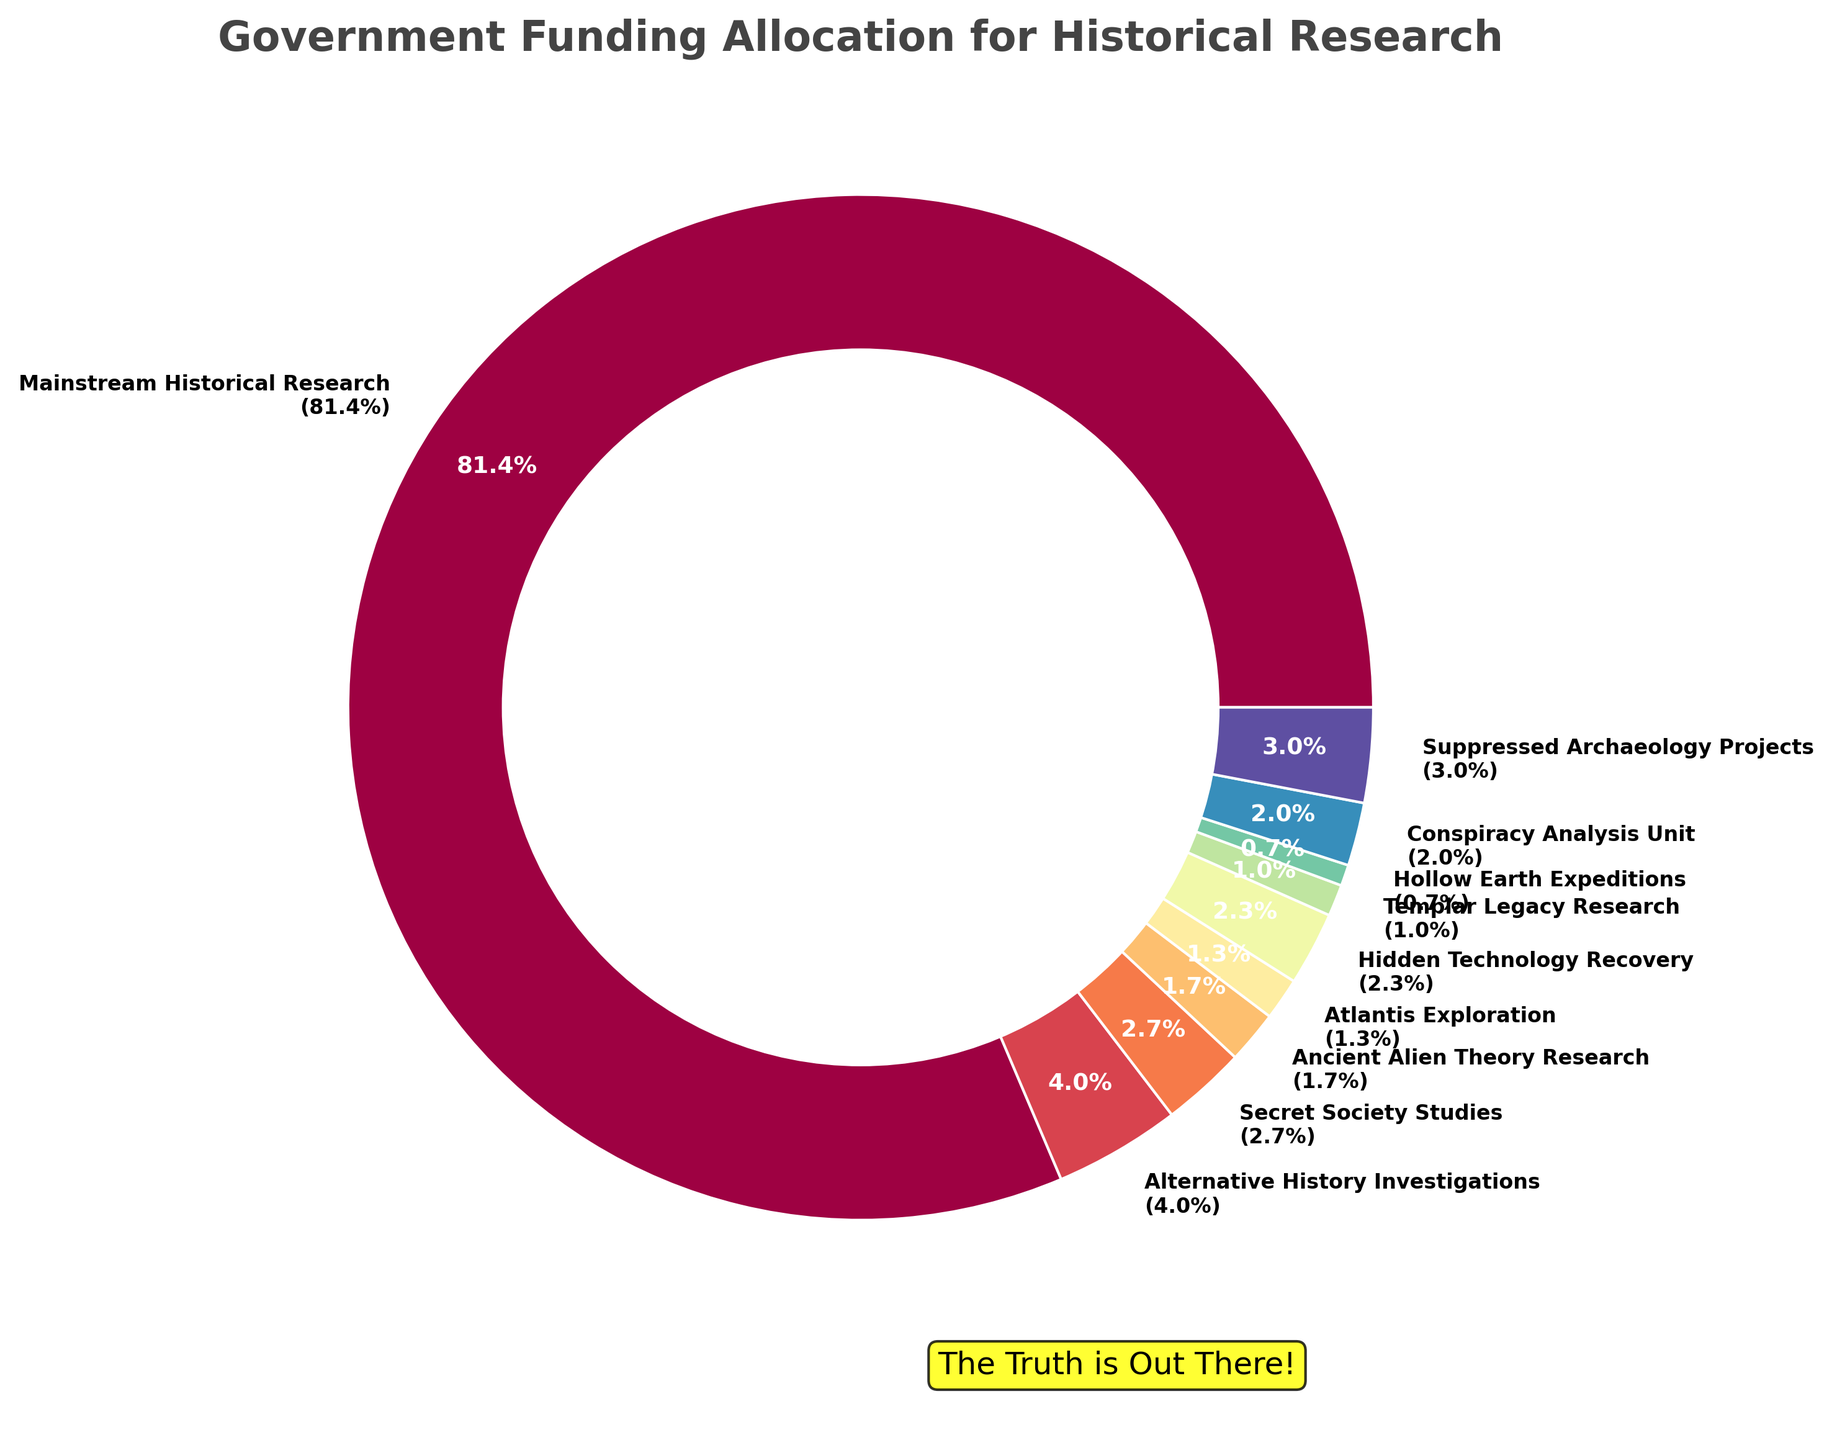Which category receives the highest funding? The segment with the label "Mainstream Historical Research (87.2%)" is the largest and indicates the highest funding.
Answer: Mainstream Historical Research How much more funding does "Mainstream Historical Research" receive compared to "Alternative History Investigations"? "Mainstream Historical Research" receives 245 million €, while "Alternative History Investigations" receives 12 million €. The difference is 245 - 12 = 233 million €.
Answer: 233 million € What is the total percentage of funding allocated to all alternative research categories combined? Sum the percentages of the smaller segments excluding "Mainstream Historical Research". The sum is (4.3+2.9+1.8+1.4+2.5+1.1+0.7+2.1) = 16.1%.
Answer: 16.1% Is the funding for "Conspiracy Analysis Unit" greater than for "Suppressed Archaeology Projects"? "Conspiracy Analysis Unit" receives 6 million €, and "Suppressed Archaeology Projects" receives 9 million €. 6 is less than 9.
Answer: No Which category has the smallest funding, and what percentage of the total is it? "Hollow Earth Expeditions" has the smallest funding with 2 million €. This is labeled as 0.7% in the chart.
Answer: Hollow Earth Expeditions, 0.7% What is the total funding for the categories of "Secret Society Studies" and "Ancient Alien Theory Research"? "Secret Society Studies" gets 8 million €, and "Ancient Alien Theory Research" gets 5 million €. The total is 8 + 5 = 13 million €.
Answer: 13 million € Which category indicates the second highest percentage of funding? "Suppressed Archaeology Projects" at 3.2%.
Answer: Suppressed Archaeology Projects Compare the funding of "Hidden Technology Recovery" and "Templar Legacy Research". Which one has more and by how much? "Hidden Technology Recovery" receives 7 million €, and "Templar Legacy Research" gets 3 million €. The difference is 7 - 3 = 4 million €.
Answer: Hidden Technology Recovery by 4 million € What visual elements emphasize the main narrative of the funding allocation? The chart uses a large central segment color indicating "Mainstream Historical Research", along with an annotation "The Truth is Out There!" and uses bright, contrasting colors to highlight smaller segments.
Answer: Large central segment, annotation, bright colors 